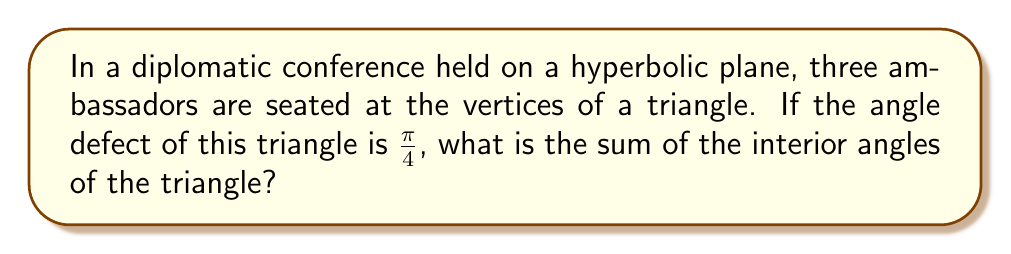Solve this math problem. Let's approach this step-by-step:

1) In Euclidean geometry, the sum of angles in a triangle is always $\pi$ radians or 180°. However, in hyperbolic geometry, this sum is always less than $\pi$.

2) The difference between $\pi$ and the sum of angles in a hyperbolic triangle is called the angle defect. Let's denote the sum of angles as $S$ and the angle defect as $D$. We can express this relationship as:

   $$D = \pi - S$$

3) In this problem, we're given that the angle defect $D = \frac{\pi}{4}$. Let's substitute this into our equation:

   $$\frac{\pi}{4} = \pi - S$$

4) To solve for $S$, we can subtract both sides from $\pi$:

   $$\pi - \frac{\pi}{4} = \pi - (\pi - S)$$
   $$\pi - \frac{\pi}{4} = S$$

5) Simplify the left side:

   $$\frac{4\pi}{4} - \frac{\pi}{4} = S$$
   $$\frac{3\pi}{4} = S$$

Therefore, the sum of the interior angles of the triangle is $\frac{3\pi}{4}$ radians.
Answer: $\frac{3\pi}{4}$ radians 